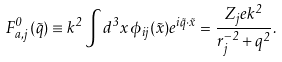Convert formula to latex. <formula><loc_0><loc_0><loc_500><loc_500>F ^ { 0 } _ { a , j } ( \vec { q } ) \equiv k ^ { 2 } \int d ^ { 3 } x \, \phi _ { i j } ( \vec { x } ) e ^ { i \vec { q } \cdot \vec { x } } = \frac { Z _ { j } e k ^ { 2 } } { r _ { j } ^ { - 2 } + q ^ { 2 } } .</formula> 